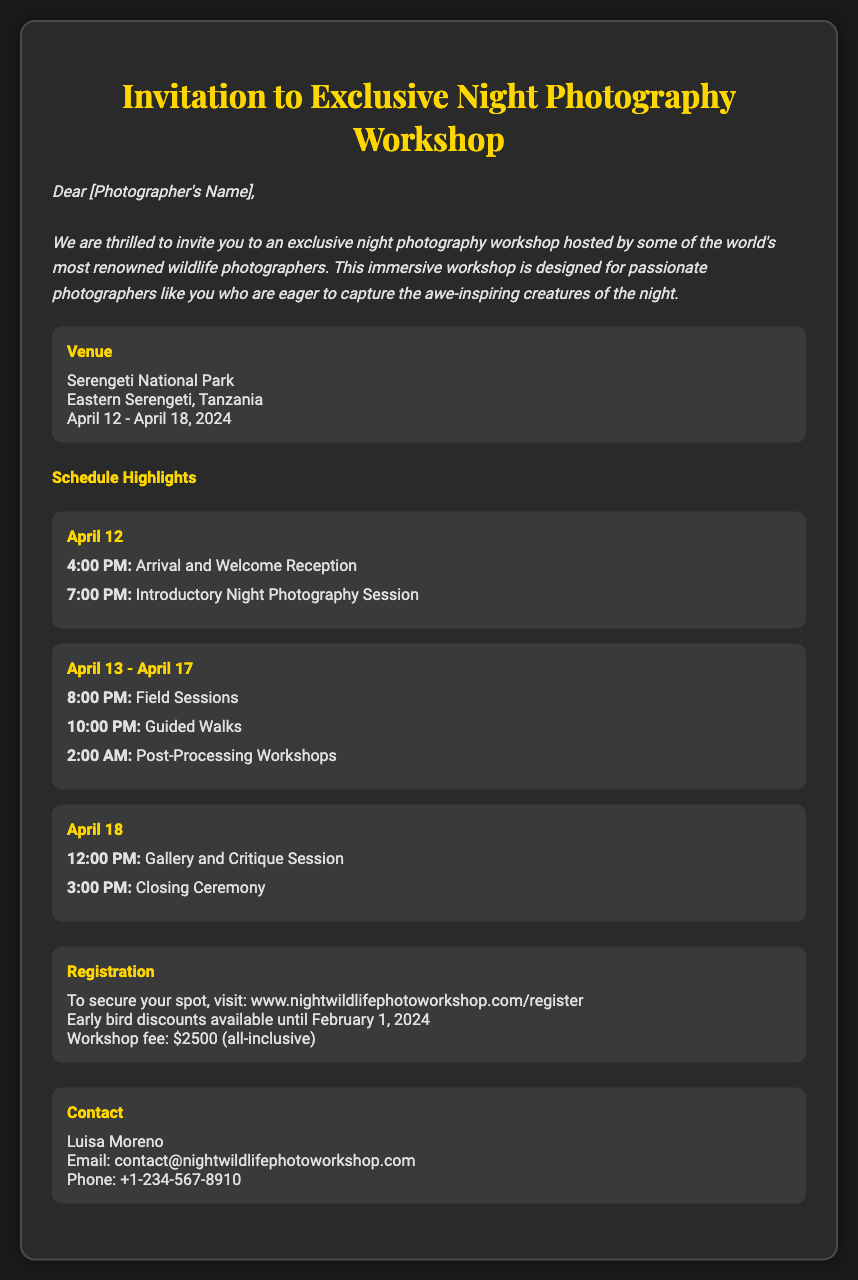what is the venue for the workshop? The venue is specified in the document as Serengeti National Park, Eastern Serengeti, Tanzania.
Answer: Serengeti National Park what are the dates for the workshop? The dates for the workshop are provided in the document as April 12 - April 18, 2024.
Answer: April 12 - April 18, 2024 who should be contacted for more information? The document lists Luisa Moreno as the contact person for inquiries.
Answer: Luisa Moreno what is the total workshop fee? The document states the workshop fee is $2500, which is the full cost for attending.
Answer: $2500 when is the early bird discount deadline? The document mentions that early bird discounts are available until February 1, 2024.
Answer: February 1, 2024 how many days does the workshop last? The workshop lasts from April 12 to April 18, 2024, which is a total of 7 days.
Answer: 7 days at what time does the introductory night photography session begin? The document specifies that the introductory session starts at 7:00 PM on April 12.
Answer: 7:00 PM what type of sessions will be held at 2:00 AM? According to the schedule, post-processing workshops are held at this time.
Answer: Post-Processing Workshops where can attendees register for the workshop? The document provides a specific URL for registration: www.nightwildlifephotoworkshop.com/register.
Answer: www.nightwildlifephotoworkshop.com/register 